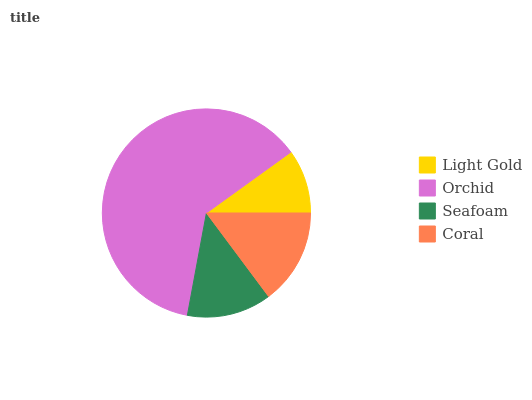Is Light Gold the minimum?
Answer yes or no. Yes. Is Orchid the maximum?
Answer yes or no. Yes. Is Seafoam the minimum?
Answer yes or no. No. Is Seafoam the maximum?
Answer yes or no. No. Is Orchid greater than Seafoam?
Answer yes or no. Yes. Is Seafoam less than Orchid?
Answer yes or no. Yes. Is Seafoam greater than Orchid?
Answer yes or no. No. Is Orchid less than Seafoam?
Answer yes or no. No. Is Coral the high median?
Answer yes or no. Yes. Is Seafoam the low median?
Answer yes or no. Yes. Is Seafoam the high median?
Answer yes or no. No. Is Coral the low median?
Answer yes or no. No. 